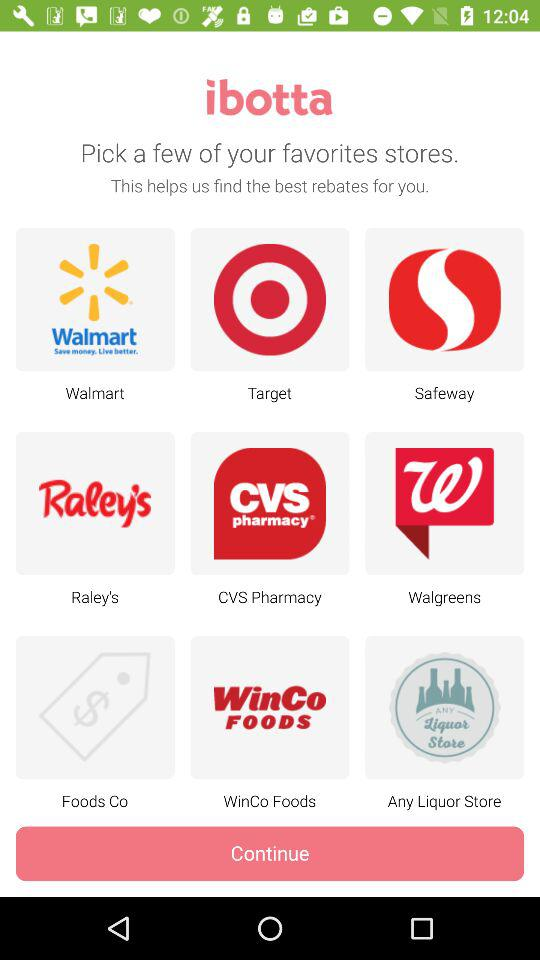What is the application name? The application name is "ibotta". 